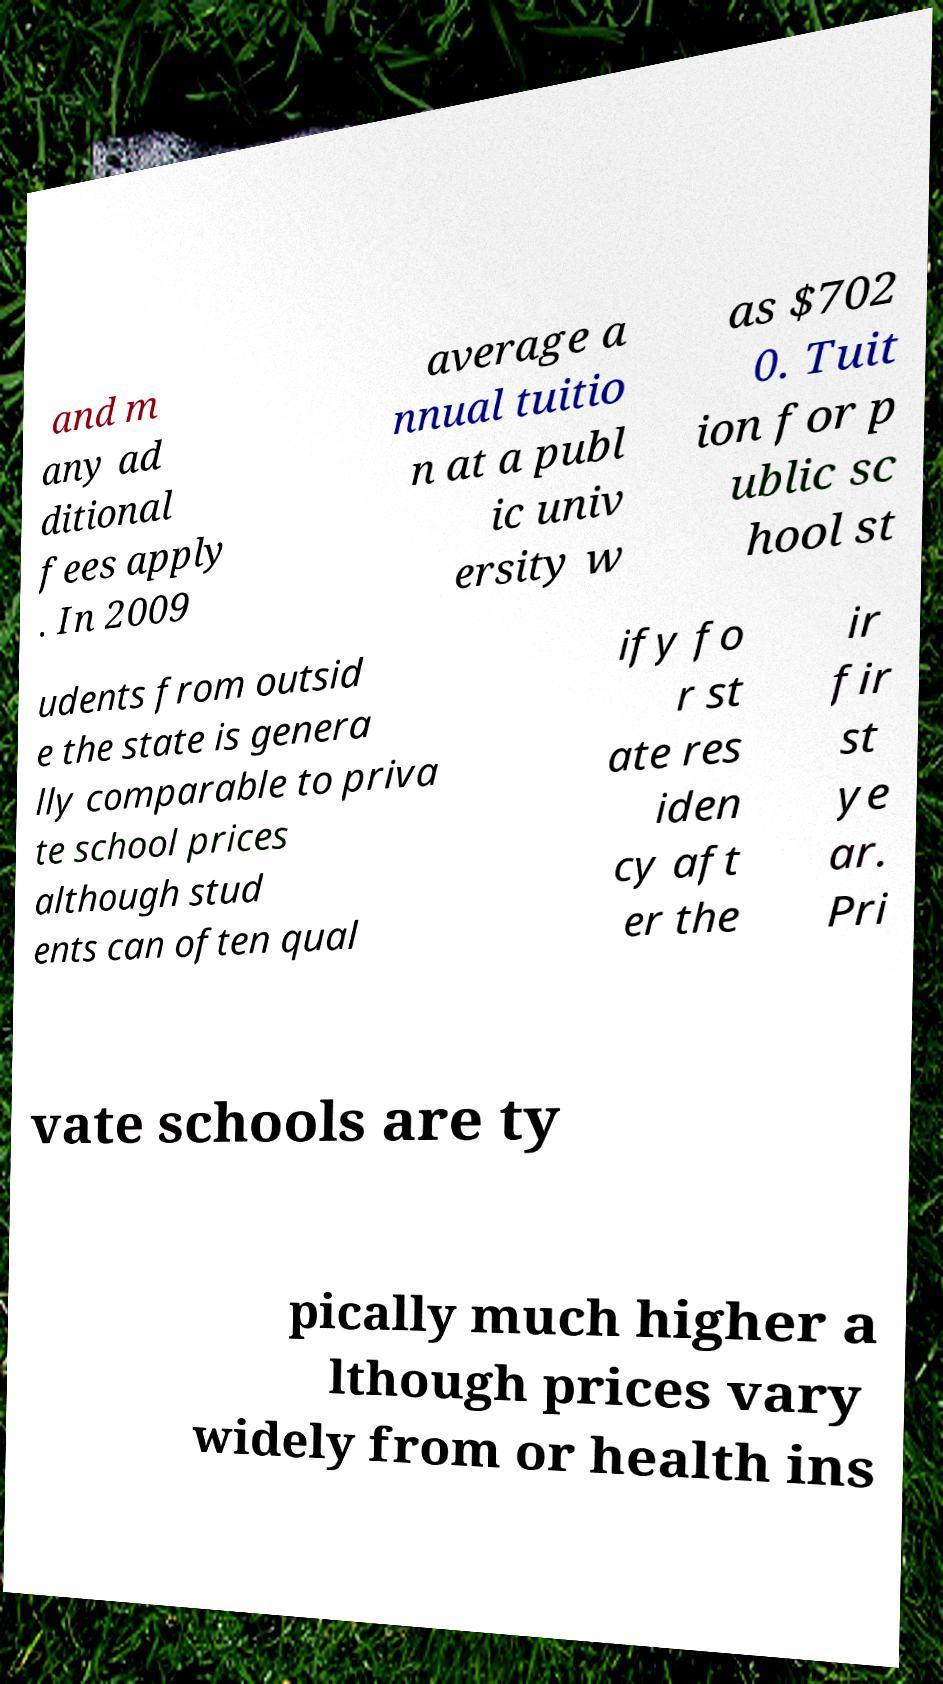Could you assist in decoding the text presented in this image and type it out clearly? and m any ad ditional fees apply . In 2009 average a nnual tuitio n at a publ ic univ ersity w as $702 0. Tuit ion for p ublic sc hool st udents from outsid e the state is genera lly comparable to priva te school prices although stud ents can often qual ify fo r st ate res iden cy aft er the ir fir st ye ar. Pri vate schools are ty pically much higher a lthough prices vary widely from or health ins 